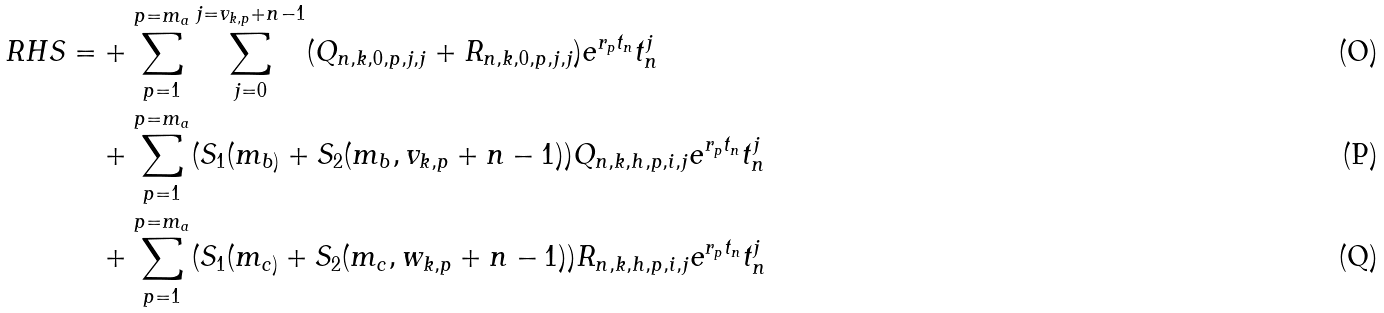<formula> <loc_0><loc_0><loc_500><loc_500>R H S = & + \sum _ { p = 1 } ^ { p = m _ { a } } \sum _ { j = 0 } ^ { j = v _ { k , p } + n - 1 } ( Q _ { n , k , 0 , p , j , j } + R _ { n , k , 0 , p , j , j } ) e ^ { r _ { p } t _ { n } } t _ { n } ^ { j } \\ & + \sum _ { p = 1 } ^ { p = m _ { a } } ( S _ { 1 } ( m _ { b ) } + S _ { 2 } ( m _ { b } , v _ { k , p } + n - 1 ) ) Q _ { n , k , h , p , i , j } e ^ { r _ { p } t _ { n } } t _ { n } ^ { j } \\ & + \sum _ { p = 1 } ^ { p = m _ { a } } ( S _ { 1 } ( m _ { c ) } + S _ { 2 } ( m _ { c } , w _ { k , p } + n - 1 ) ) R _ { n , k , h , p , i , j } e ^ { r _ { p } t _ { n } } t _ { n } ^ { j }</formula> 